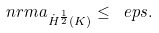<formula> <loc_0><loc_0><loc_500><loc_500>\ n r m { a } _ { \dot { H } ^ { \frac { 1 } { 2 } } ( K ) } \leq \ e p s .</formula> 